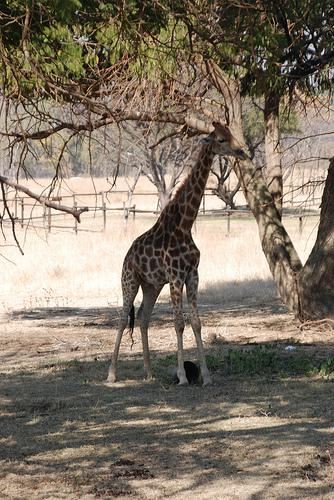In one sentence, explain the primary subject in the image and their surroundings. The giraffe with a split in its ear stands on a patch of green amid dead grass in a field, near a tree with green leaves and a wooden fence in the background. Give a brief overview of the main subject in the picture and the things around them. A giraffe with a long neck and distinct horns stands next to a tree casting a shadow, with a wooden fence, dry grass, and a black flower pot on the ground nearby. Provide a cursory description of the main object in the picture and its environment. A shaded giraffe with a short mane is standing in a field with an old wooden gate, green grass, and a huge tree with green leaves. Briefly mention the focal point of the image and the elements around it. A giraffe with brown spots and a small white mouth stands by a tree in a field with a wooden fence, some green grass, and a bucket near its leg. Describe the essential element of the image and its environment in a single sentence. A giraffe with a short mane on its neck is standing under a tree with a large rock and green grass, in a field enclosed by a wooden fence and trees with dead limbs. In a detailed sentence, explain the primary subject of the image and their surroundings. A giraffe with spotted body and long neck stands next to a tree, facing right in a field with a rickety old fence, a large rock, and dry grass in the background. Provide a brief description of the main focus in the image and its actions. A giraffe with white feet is eating under a tree, looking at the camera, and standing on a patch of dead grass in the shade. Mention the central figure in the image and a few things happening around it. A brown and white giraffe with long legs and a dark tail stands near a tree in a field, with a wooden fence, a food dish, and shadows of trees on the ground. In one sentence, describe the central character in the image and a few surrounding details. A giraffe with a dark tail, brown spots, and long legs is standing in the shade under a tree, with a brown fence, dry grass, and trees with dead limbs in the background. Describe the key subject of the image and their current actions. A giraffe with long neck and eye-catching horns is standing under a tree with a large shadow, eating and looking at the camera. 